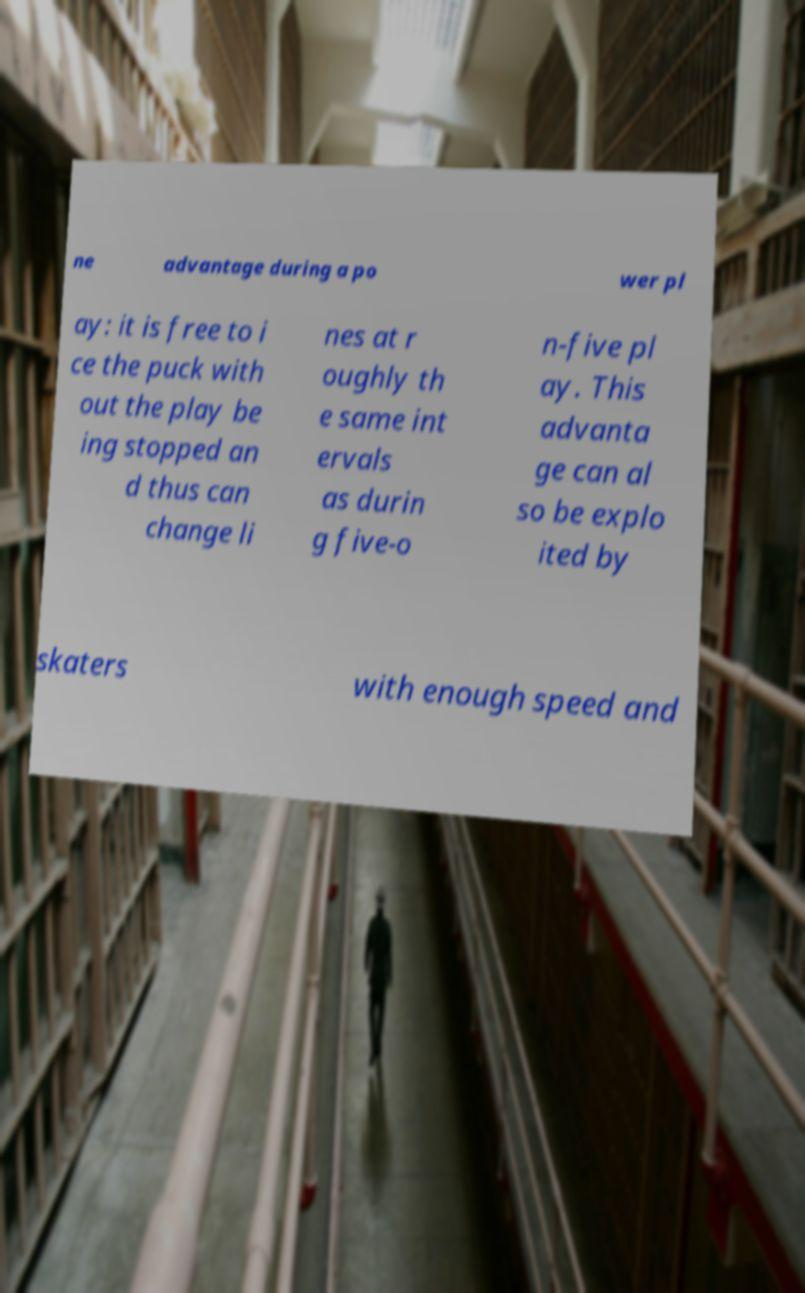Could you assist in decoding the text presented in this image and type it out clearly? ne advantage during a po wer pl ay: it is free to i ce the puck with out the play be ing stopped an d thus can change li nes at r oughly th e same int ervals as durin g five-o n-five pl ay. This advanta ge can al so be explo ited by skaters with enough speed and 